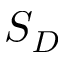<formula> <loc_0><loc_0><loc_500><loc_500>S _ { D }</formula> 